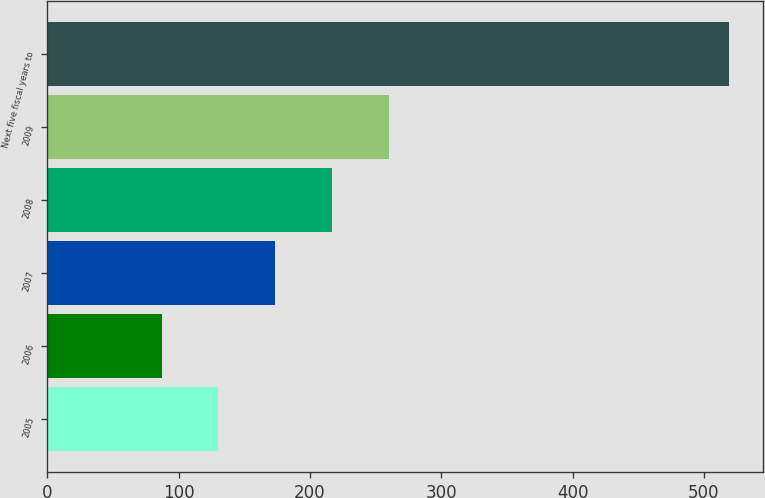<chart> <loc_0><loc_0><loc_500><loc_500><bar_chart><fcel>2005<fcel>2006<fcel>2007<fcel>2008<fcel>2009<fcel>Next five fiscal years to<nl><fcel>130.2<fcel>87<fcel>173.4<fcel>216.6<fcel>259.8<fcel>519<nl></chart> 